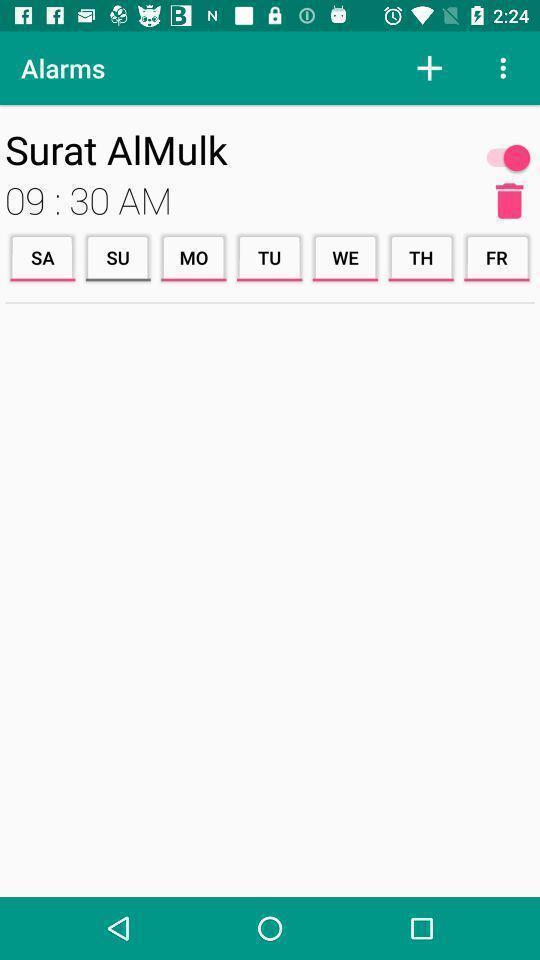Describe the key features of this screenshot. Screen displaying multiple days with time. 